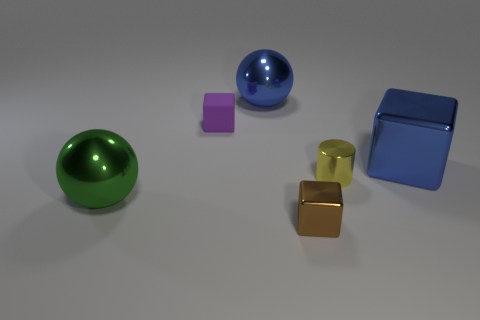What number of large objects are shiny balls or blue metallic spheres?
Your answer should be very brief. 2. There is a ball that is the same color as the big shiny block; what is its material?
Ensure brevity in your answer.  Metal. Is the material of the small block that is right of the small purple block the same as the large object that is to the right of the brown thing?
Your answer should be very brief. Yes. Are any big metal spheres visible?
Make the answer very short. Yes. Is the number of cubes that are in front of the big blue shiny ball greater than the number of brown objects that are behind the tiny brown metallic block?
Your answer should be very brief. Yes. There is a small purple object that is the same shape as the small brown thing; what is it made of?
Offer a very short reply. Rubber. Do the shiny cube right of the small metal block and the metallic ball that is behind the small yellow metal object have the same color?
Make the answer very short. Yes. What is the shape of the tiny rubber thing?
Your answer should be compact. Cube. Are there more metallic spheres in front of the purple block than large gray rubber cylinders?
Your response must be concise. Yes. What shape is the green thing left of the yellow object?
Your response must be concise. Sphere. 